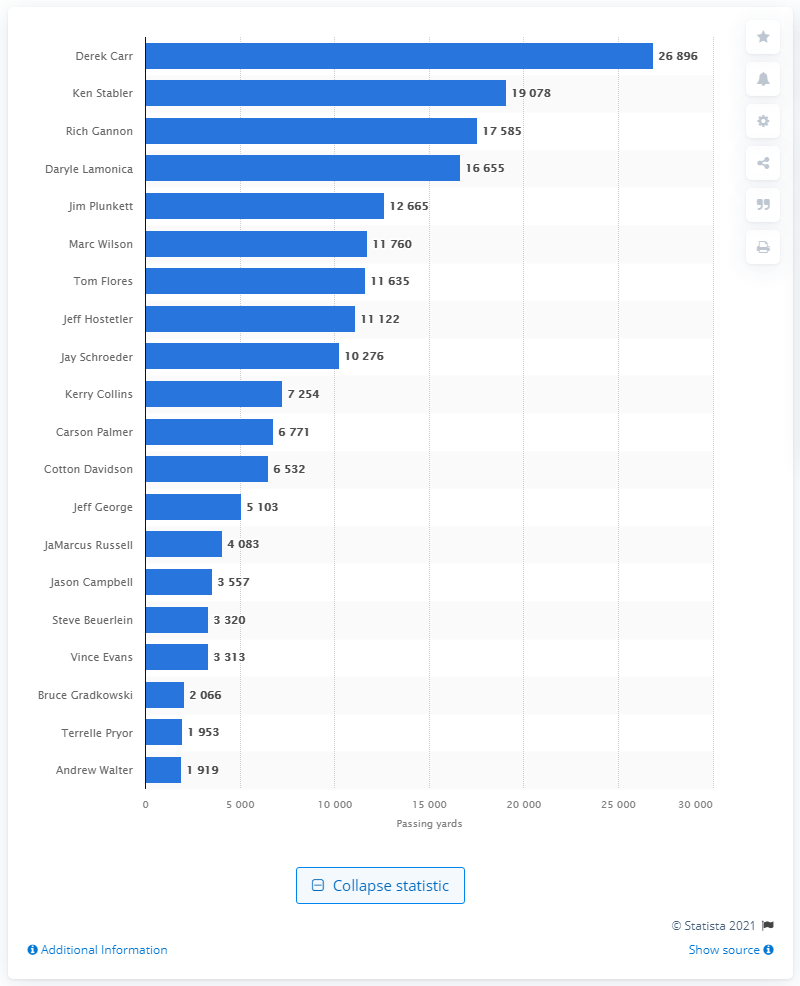Outline some significant characteristics in this image. The individual who holds the record for the most career passing yards as a member of the Las Vegas Raiders is Derek Carr. 